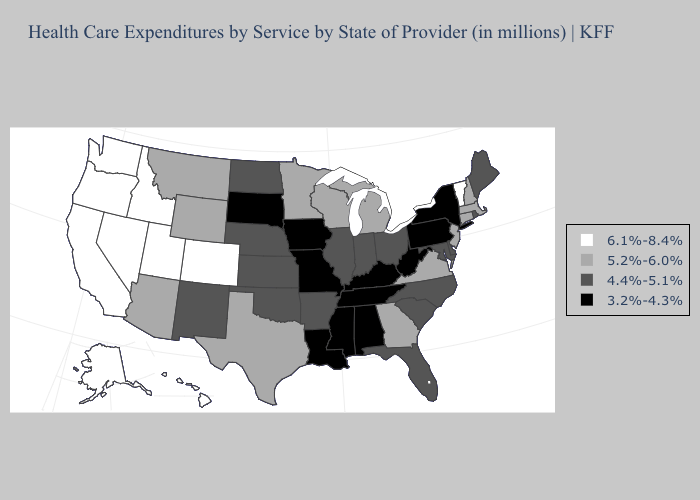Name the states that have a value in the range 4.4%-5.1%?
Keep it brief. Arkansas, Delaware, Florida, Illinois, Indiana, Kansas, Maine, Maryland, Nebraska, New Mexico, North Carolina, North Dakota, Ohio, Oklahoma, Rhode Island, South Carolina. What is the lowest value in states that border North Dakota?
Write a very short answer. 3.2%-4.3%. Does Missouri have the highest value in the MidWest?
Quick response, please. No. What is the lowest value in states that border Mississippi?
Quick response, please. 3.2%-4.3%. Does New Mexico have a higher value than Oregon?
Write a very short answer. No. Does Utah have the highest value in the USA?
Keep it brief. Yes. Name the states that have a value in the range 4.4%-5.1%?
Keep it brief. Arkansas, Delaware, Florida, Illinois, Indiana, Kansas, Maine, Maryland, Nebraska, New Mexico, North Carolina, North Dakota, Ohio, Oklahoma, Rhode Island, South Carolina. Which states have the lowest value in the West?
Answer briefly. New Mexico. What is the value of Montana?
Answer briefly. 5.2%-6.0%. Among the states that border Kansas , which have the lowest value?
Be succinct. Missouri. Name the states that have a value in the range 5.2%-6.0%?
Answer briefly. Arizona, Connecticut, Georgia, Massachusetts, Michigan, Minnesota, Montana, New Hampshire, New Jersey, Texas, Virginia, Wisconsin, Wyoming. Among the states that border West Virginia , does Maryland have the lowest value?
Short answer required. No. Is the legend a continuous bar?
Give a very brief answer. No. Name the states that have a value in the range 6.1%-8.4%?
Quick response, please. Alaska, California, Colorado, Hawaii, Idaho, Nevada, Oregon, Utah, Vermont, Washington. Name the states that have a value in the range 4.4%-5.1%?
Write a very short answer. Arkansas, Delaware, Florida, Illinois, Indiana, Kansas, Maine, Maryland, Nebraska, New Mexico, North Carolina, North Dakota, Ohio, Oklahoma, Rhode Island, South Carolina. 